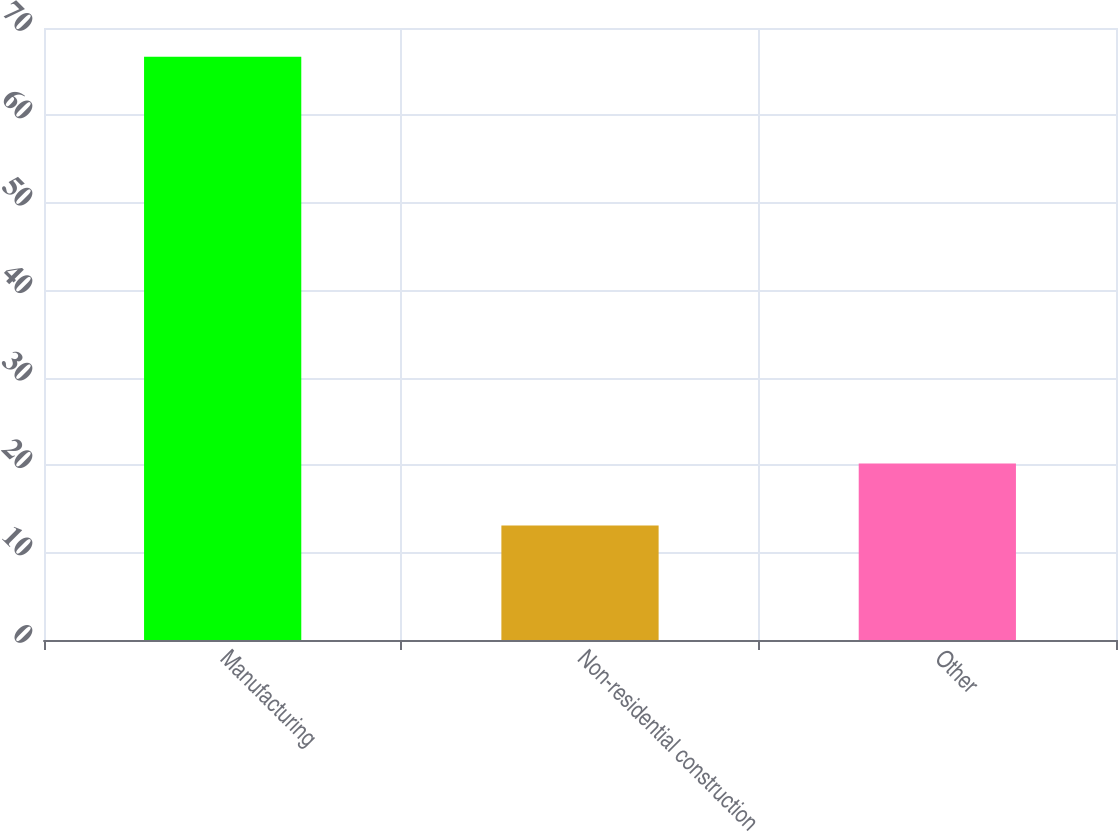<chart> <loc_0><loc_0><loc_500><loc_500><bar_chart><fcel>Manufacturing<fcel>Non-residential construction<fcel>Other<nl><fcel>66.7<fcel>13.1<fcel>20.2<nl></chart> 